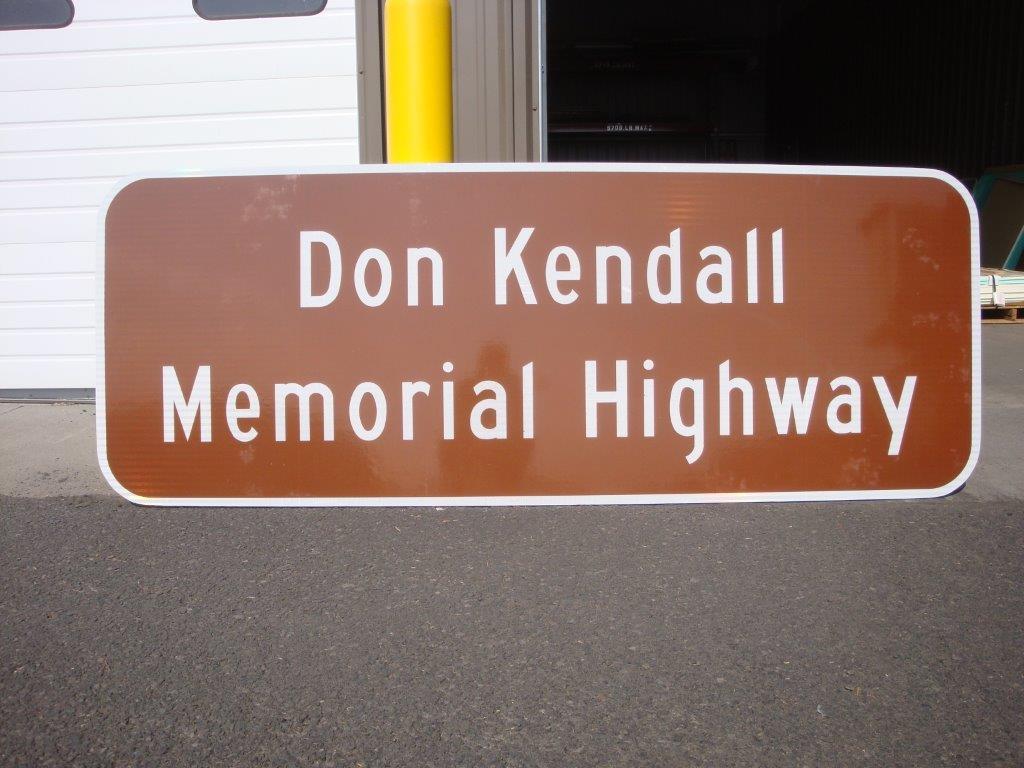What is the name of this road?
Ensure brevity in your answer.  Don kendall memorial highway. Where is situated memorial highway?
Ensure brevity in your answer.  Don kendall. 